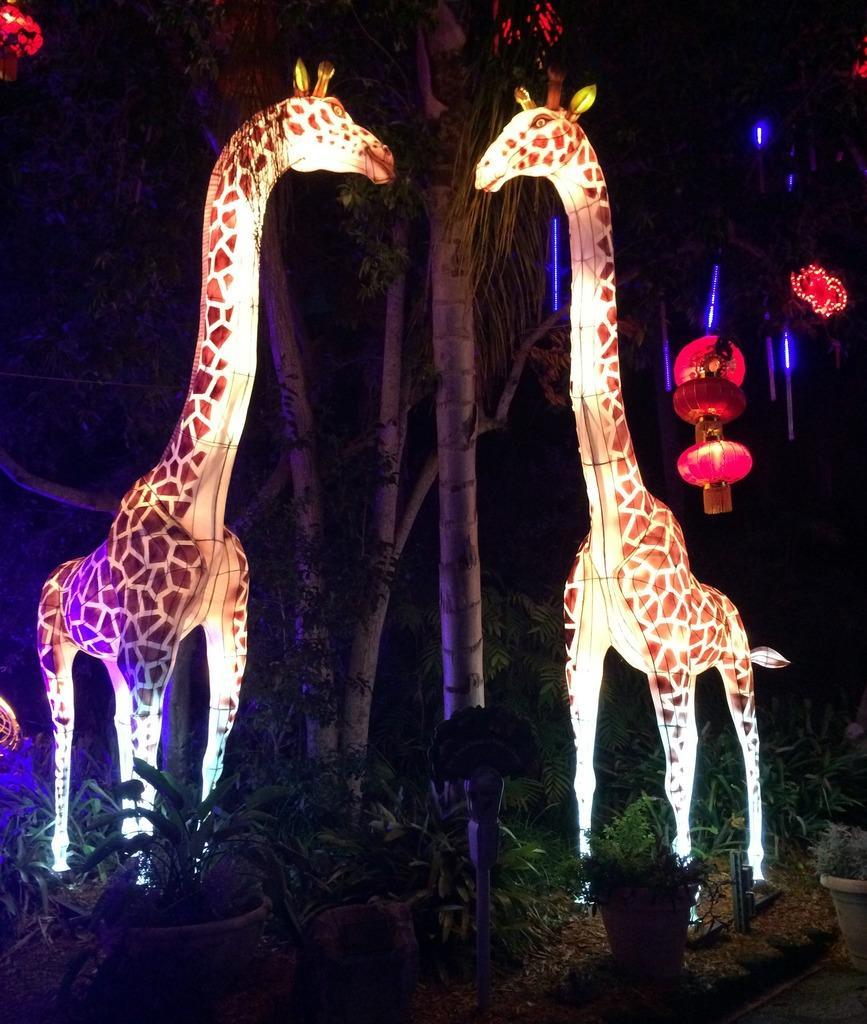How would you summarize this image in a sentence or two? In this picture I can observe statues of two giraffes. There are some plants on the ground. I can observe some trees. The background is completely dark. 